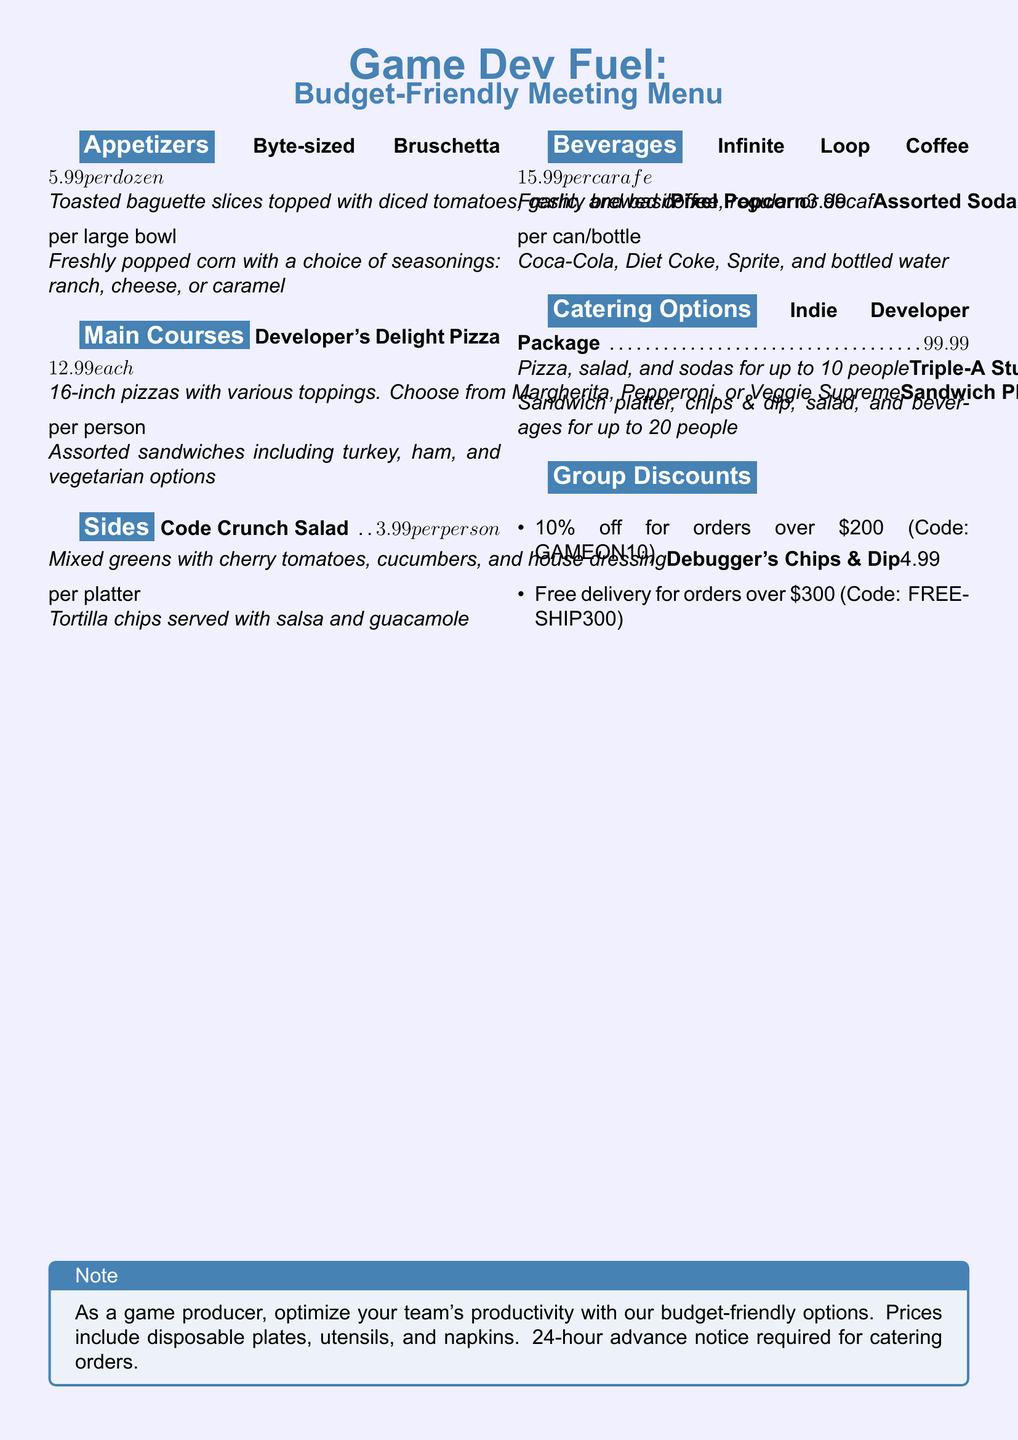What is the price of the Byte-sized Bruschetta? The price for the Byte-sized Bruschetta is listed in the "Appetizers" section of the menu as $5.99 per dozen.
Answer: $5.99 per dozen How many people does the Indie Developer Package serve? The Indie Developer Package is designed to serve up to 10 people, as stated in the "Catering Options" section of the menu.
Answer: 10 people What is the discount code for 10% off orders over $200? The discount code for obtaining a 10% discount on orders exceeding $200 is provided in the "Group Discounts" section.
Answer: GAMEON10 What is included in the Triple-A Studio Spread? The Triple-A Studio Spread includes a sandwich platter, chips & dip, salad, and beverages, as detailed in the "Catering Options" section of the menu.
Answer: Sandwich platter, chips & dip, salad, and beverages What is the cost of the Infinite Loop Coffee? The cost for the Infinite Loop Coffee is mentioned in the "Beverages" section of the menu, specifically for freshly brewed coffee (regular or decaf).
Answer: $15.99 per carafe 